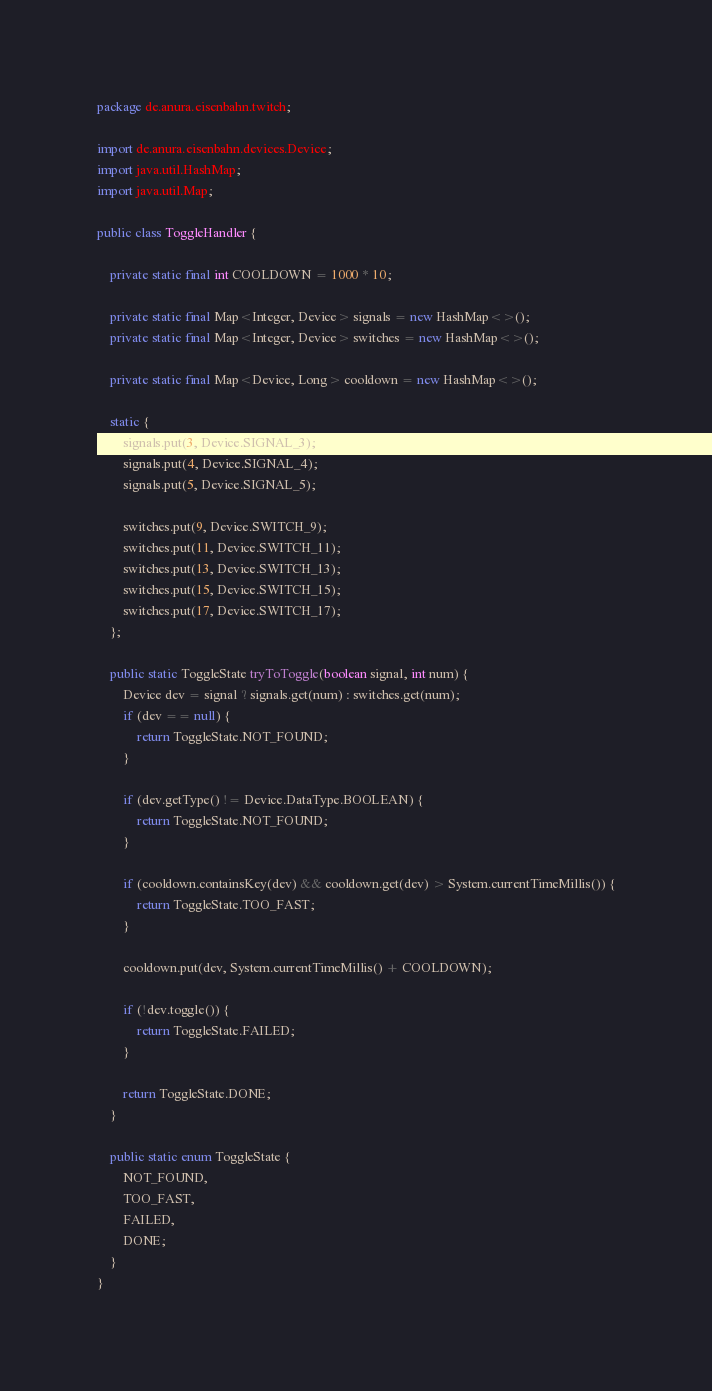Convert code to text. <code><loc_0><loc_0><loc_500><loc_500><_Java_>package de.anura.eisenbahn.twitch;

import de.anura.eisenbahn.devices.Device;
import java.util.HashMap;
import java.util.Map;

public class ToggleHandler {

    private static final int COOLDOWN = 1000 * 10;

    private static final Map<Integer, Device> signals = new HashMap<>();
    private static final Map<Integer, Device> switches = new HashMap<>();

    private static final Map<Device, Long> cooldown = new HashMap<>();

    static {
        signals.put(3, Device.SIGNAL_3);
        signals.put(4, Device.SIGNAL_4);
        signals.put(5, Device.SIGNAL_5);

        switches.put(9, Device.SWITCH_9);
        switches.put(11, Device.SWITCH_11);
        switches.put(13, Device.SWITCH_13);
        switches.put(15, Device.SWITCH_15);
        switches.put(17, Device.SWITCH_17);
    };

    public static ToggleState tryToToggle(boolean signal, int num) {
        Device dev = signal ? signals.get(num) : switches.get(num);
        if (dev == null) {
            return ToggleState.NOT_FOUND;
        }

        if (dev.getType() != Device.DataType.BOOLEAN) {
            return ToggleState.NOT_FOUND;
        }

        if (cooldown.containsKey(dev) && cooldown.get(dev) > System.currentTimeMillis()) {
            return ToggleState.TOO_FAST;
        }

        cooldown.put(dev, System.currentTimeMillis() + COOLDOWN);

        if (!dev.toggle()) {
            return ToggleState.FAILED;
        }

        return ToggleState.DONE;
    }

    public static enum ToggleState {
        NOT_FOUND,
        TOO_FAST,
        FAILED,
        DONE;
    }
}
</code> 